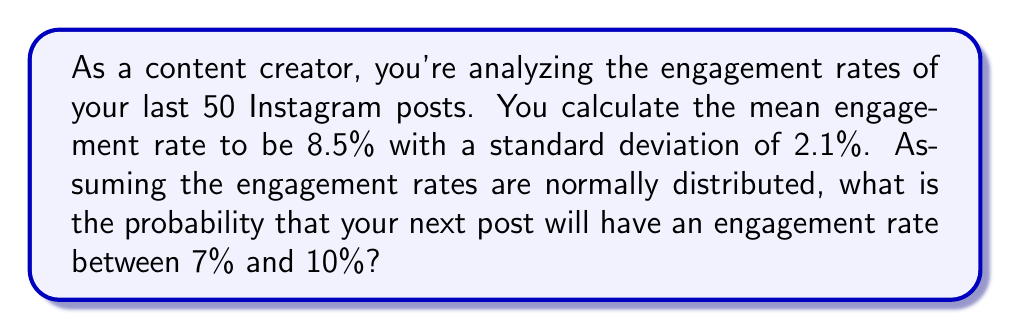Can you answer this question? To solve this problem, we need to use the properties of the normal distribution and the concept of z-scores.

1. First, let's identify our given information:
   - Mean (μ) = 8.5%
   - Standard deviation (σ) = 2.1%
   - We want to find the probability of an engagement rate between 7% and 10%

2. We need to convert these values to z-scores using the formula:
   $$ z = \frac{x - \mu}{\sigma} $$

   For 7%: $z_1 = \frac{7 - 8.5}{2.1} = -0.7143$
   For 10%: $z_2 = \frac{10 - 8.5}{2.1} = 0.7143$

3. Now, we need to find the area under the standard normal curve between these two z-scores.

4. Using a standard normal distribution table or calculator, we can find:
   P(z < 0.7143) ≈ 0.7624
   P(z < -0.7143) ≈ 0.2376

5. The probability we're looking for is the difference between these two values:
   P(-0.7143 < z < 0.7143) = 0.7624 - 0.2376 = 0.5248

6. Convert to a percentage: 0.5248 * 100 = 52.48%

Therefore, there is approximately a 52.48% chance that your next post will have an engagement rate between 7% and 10%.
Answer: 52.48% 